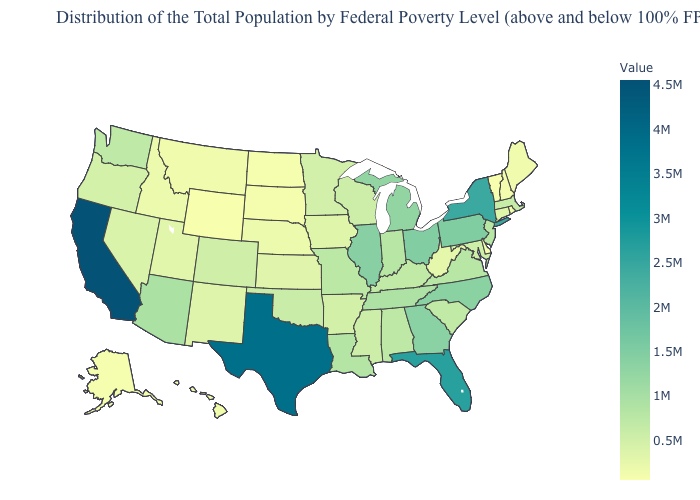Does Tennessee have the highest value in the USA?
Keep it brief. No. Does Rhode Island have the lowest value in the Northeast?
Give a very brief answer. No. Among the states that border Connecticut , does New York have the highest value?
Keep it brief. Yes. Does North Dakota have the lowest value in the MidWest?
Be succinct. Yes. Which states have the highest value in the USA?
Short answer required. California. 